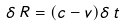<formula> <loc_0><loc_0><loc_500><loc_500>\delta \, R = ( c - v ) \delta \, t</formula> 